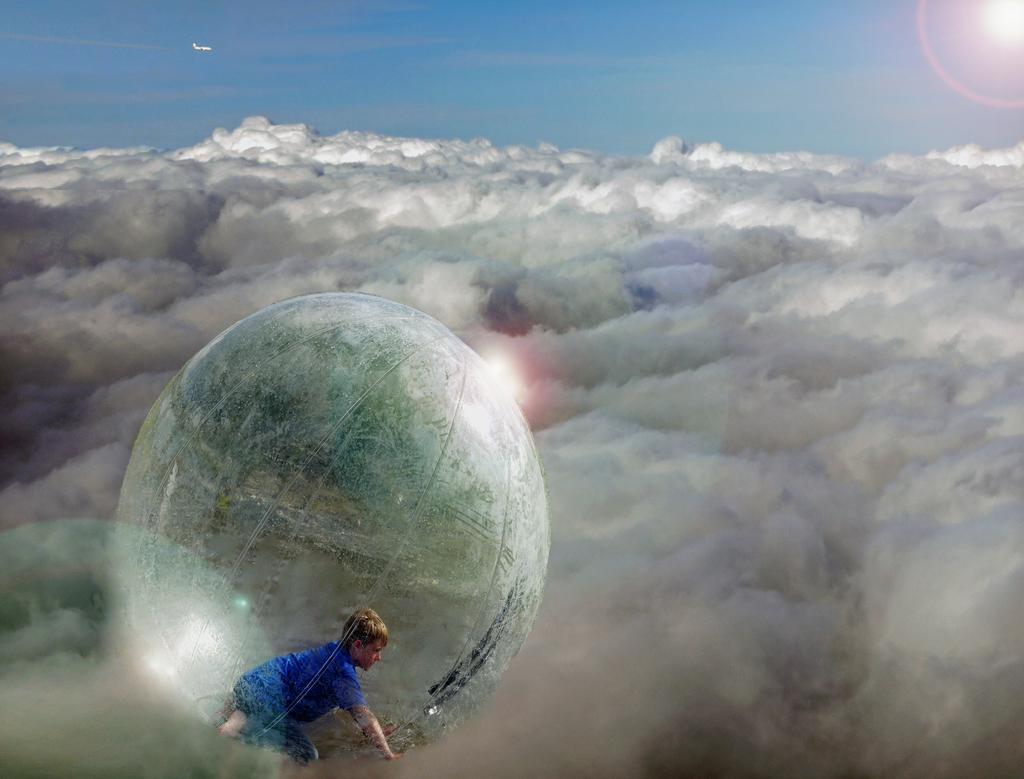What can be observed about the nature of the image? The image is edited. What can be seen in the sky in the image? There are clouds in the image. What is the kid doing in the image? The kid is inside a balloon in the image. What else is present in the sky in the image? There is an airplane flying in the background of the image. What type of spark can be seen coming from the airplane in the image? There is no spark visible coming from the airplane in the image. 